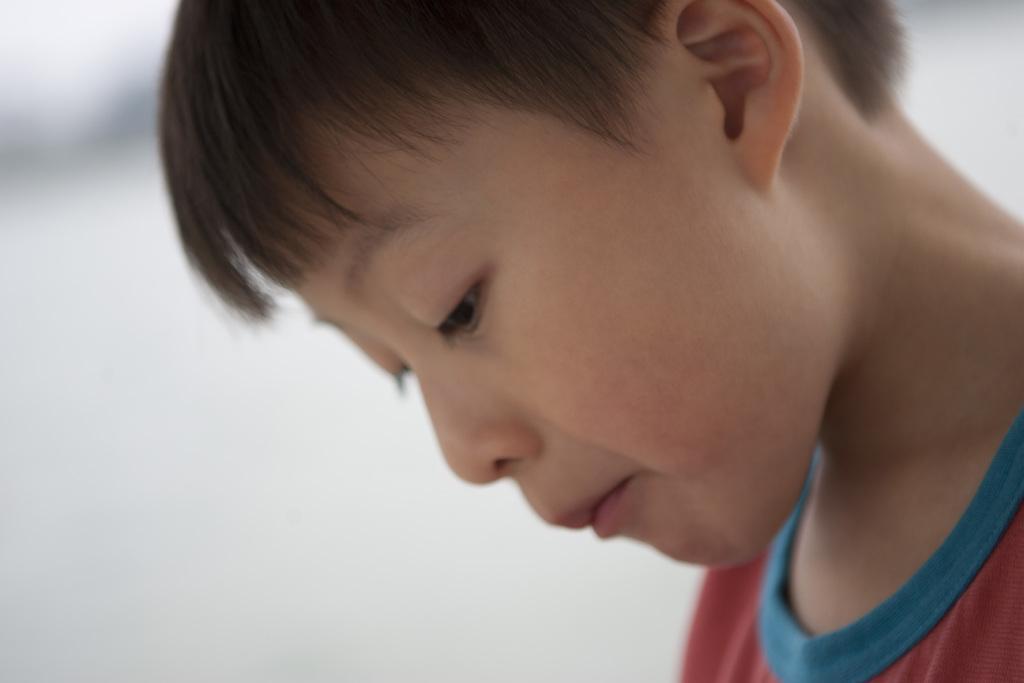In one or two sentences, can you explain what this image depicts? In this picture, we see a boy is wearing a red T-shirt. We see two eyes, nose, mouth and an ear of the boy. In the background, it is white in color. 